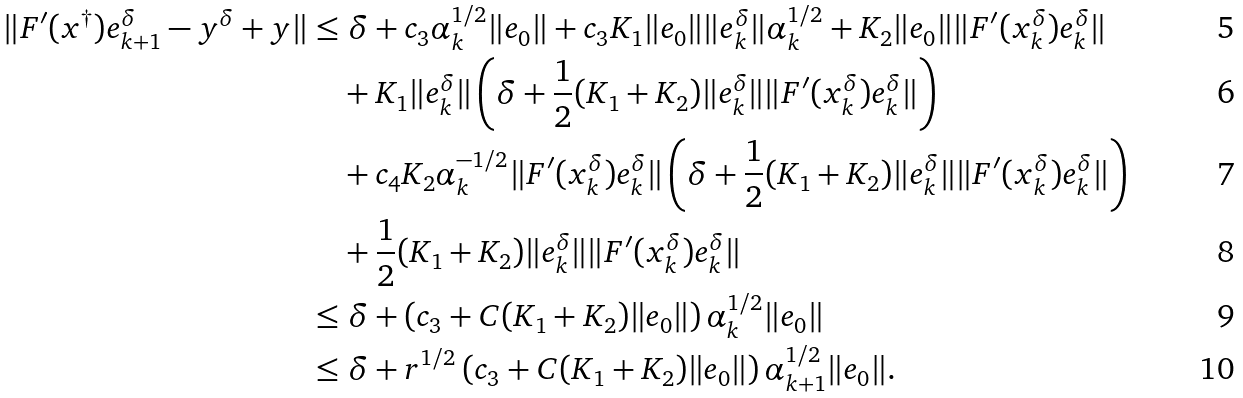<formula> <loc_0><loc_0><loc_500><loc_500>\| F ^ { \prime } ( x ^ { \dag } ) e _ { k + 1 } ^ { \delta } - y ^ { \delta } + y \| & \leq \delta + c _ { 3 } \alpha _ { k } ^ { 1 / 2 } \| e _ { 0 } \| + c _ { 3 } K _ { 1 } \| e _ { 0 } \| \| e _ { k } ^ { \delta } \| \alpha _ { k } ^ { 1 / 2 } + K _ { 2 } \| e _ { 0 } \| \| F ^ { \prime } ( x _ { k } ^ { \delta } ) e _ { k } ^ { \delta } \| \\ & \quad + K _ { 1 } \| e _ { k } ^ { \delta } \| \left ( \delta + \frac { 1 } { 2 } ( K _ { 1 } + K _ { 2 } ) \| e _ { k } ^ { \delta } \| \| F ^ { \prime } ( x _ { k } ^ { \delta } ) e _ { k } ^ { \delta } \| \right ) \\ & \quad + c _ { 4 } K _ { 2 } \alpha _ { k } ^ { - 1 / 2 } \| F ^ { \prime } ( x _ { k } ^ { \delta } ) e _ { k } ^ { \delta } \| \left ( \delta + \frac { 1 } { 2 } ( K _ { 1 } + K _ { 2 } ) \| e _ { k } ^ { \delta } \| \| F ^ { \prime } ( x _ { k } ^ { \delta } ) e _ { k } ^ { \delta } \| \right ) \\ & \quad + \frac { 1 } { 2 } ( K _ { 1 } + K _ { 2 } ) \| e _ { k } ^ { \delta } \| \| F ^ { \prime } ( x _ { k } ^ { \delta } ) e _ { k } ^ { \delta } \| \\ & \leq \delta + \left ( c _ { 3 } + C ( K _ { 1 } + K _ { 2 } ) \| e _ { 0 } \| \right ) \alpha _ { k } ^ { 1 / 2 } \| e _ { 0 } \| \\ & \leq \delta + r ^ { 1 / 2 } \left ( c _ { 3 } + C ( K _ { 1 } + K _ { 2 } ) \| e _ { 0 } \| \right ) \alpha _ { k + 1 } ^ { 1 / 2 } \| e _ { 0 } \| .</formula> 